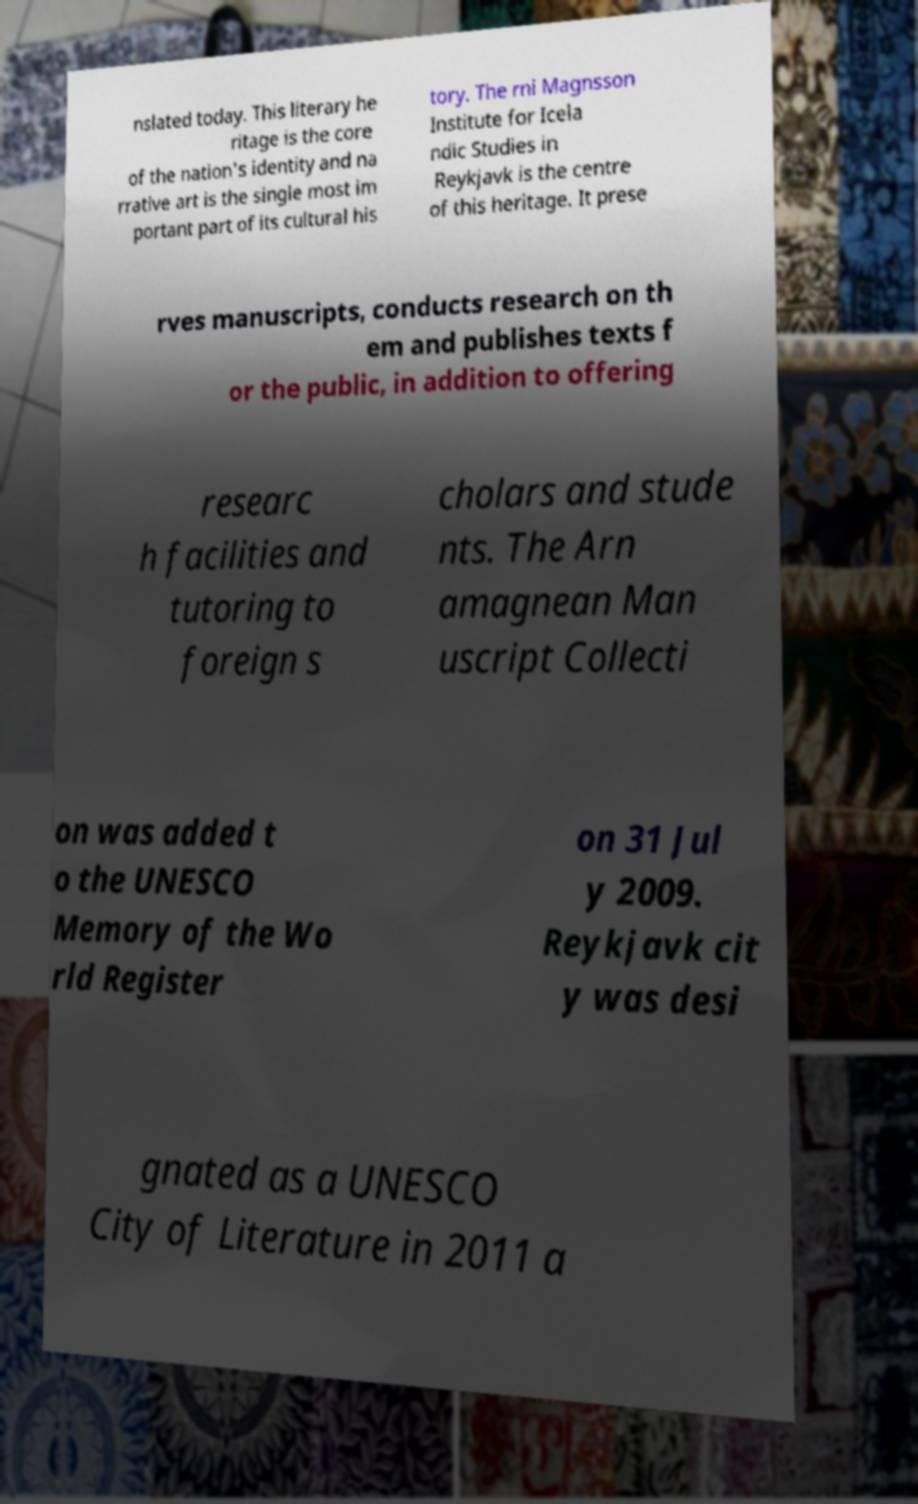There's text embedded in this image that I need extracted. Can you transcribe it verbatim? nslated today. This literary he ritage is the core of the nation's identity and na rrative art is the single most im portant part of its cultural his tory. The rni Magnsson Institute for Icela ndic Studies in Reykjavk is the centre of this heritage. It prese rves manuscripts, conducts research on th em and publishes texts f or the public, in addition to offering researc h facilities and tutoring to foreign s cholars and stude nts. The Arn amagnean Man uscript Collecti on was added t o the UNESCO Memory of the Wo rld Register on 31 Jul y 2009. Reykjavk cit y was desi gnated as a UNESCO City of Literature in 2011 a 